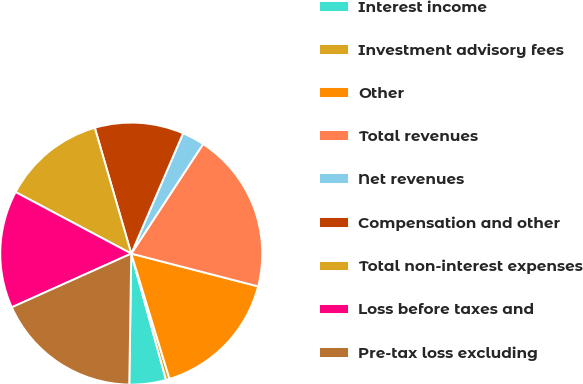<chart> <loc_0><loc_0><loc_500><loc_500><pie_chart><fcel>Interest income<fcel>Investment advisory fees<fcel>Other<fcel>Total revenues<fcel>Net revenues<fcel>Compensation and other<fcel>Total non-interest expenses<fcel>Loss before taxes and<fcel>Pre-tax loss excluding<nl><fcel>4.52%<fcel>0.44%<fcel>16.26%<fcel>19.79%<fcel>2.76%<fcel>10.96%<fcel>12.73%<fcel>14.5%<fcel>18.03%<nl></chart> 